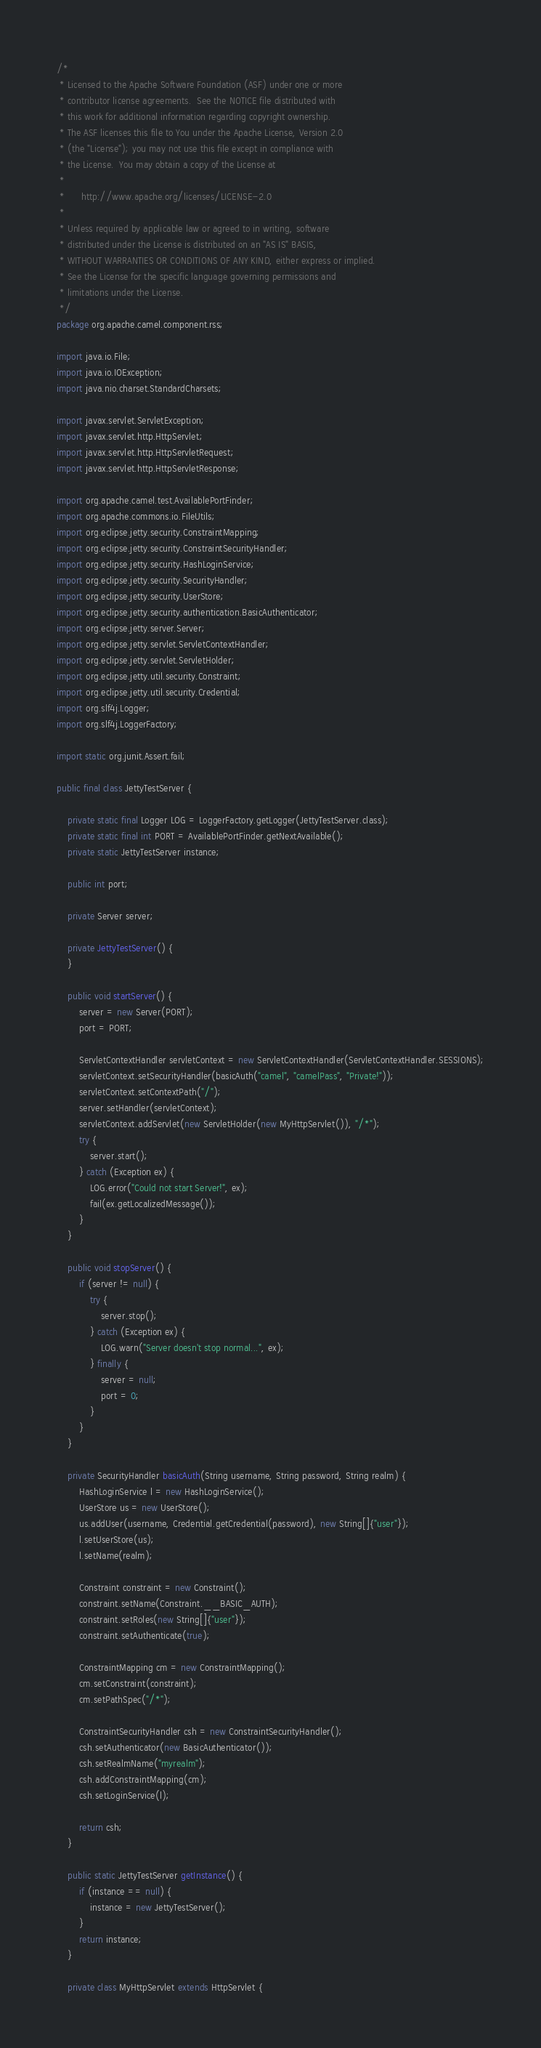<code> <loc_0><loc_0><loc_500><loc_500><_Java_>/*
 * Licensed to the Apache Software Foundation (ASF) under one or more
 * contributor license agreements.  See the NOTICE file distributed with
 * this work for additional information regarding copyright ownership.
 * The ASF licenses this file to You under the Apache License, Version 2.0
 * (the "License"); you may not use this file except in compliance with
 * the License.  You may obtain a copy of the License at
 *
 *      http://www.apache.org/licenses/LICENSE-2.0
 *
 * Unless required by applicable law or agreed to in writing, software
 * distributed under the License is distributed on an "AS IS" BASIS,
 * WITHOUT WARRANTIES OR CONDITIONS OF ANY KIND, either express or implied.
 * See the License for the specific language governing permissions and
 * limitations under the License.
 */
package org.apache.camel.component.rss;

import java.io.File;
import java.io.IOException;
import java.nio.charset.StandardCharsets;

import javax.servlet.ServletException;
import javax.servlet.http.HttpServlet;
import javax.servlet.http.HttpServletRequest;
import javax.servlet.http.HttpServletResponse;

import org.apache.camel.test.AvailablePortFinder;
import org.apache.commons.io.FileUtils;
import org.eclipse.jetty.security.ConstraintMapping;
import org.eclipse.jetty.security.ConstraintSecurityHandler;
import org.eclipse.jetty.security.HashLoginService;
import org.eclipse.jetty.security.SecurityHandler;
import org.eclipse.jetty.security.UserStore;
import org.eclipse.jetty.security.authentication.BasicAuthenticator;
import org.eclipse.jetty.server.Server;
import org.eclipse.jetty.servlet.ServletContextHandler;
import org.eclipse.jetty.servlet.ServletHolder;
import org.eclipse.jetty.util.security.Constraint;
import org.eclipse.jetty.util.security.Credential;
import org.slf4j.Logger;
import org.slf4j.LoggerFactory;

import static org.junit.Assert.fail;

public final class JettyTestServer {

    private static final Logger LOG = LoggerFactory.getLogger(JettyTestServer.class);
    private static final int PORT = AvailablePortFinder.getNextAvailable();
    private static JettyTestServer instance;

    public int port;

    private Server server;

    private JettyTestServer() {
    }

    public void startServer() {
        server = new Server(PORT);
        port = PORT;

        ServletContextHandler servletContext = new ServletContextHandler(ServletContextHandler.SESSIONS);
        servletContext.setSecurityHandler(basicAuth("camel", "camelPass", "Private!"));
        servletContext.setContextPath("/");
        server.setHandler(servletContext);
        servletContext.addServlet(new ServletHolder(new MyHttpServlet()), "/*");
        try {
            server.start();
        } catch (Exception ex) {
            LOG.error("Could not start Server!", ex);
            fail(ex.getLocalizedMessage());
        }
    }

    public void stopServer() {
        if (server != null) {
            try {
                server.stop();
            } catch (Exception ex) {
                LOG.warn("Server doesn't stop normal...", ex);
            } finally {
                server = null;
                port = 0;
            }
        }
    }

    private SecurityHandler basicAuth(String username, String password, String realm) {
        HashLoginService l = new HashLoginService();
        UserStore us = new UserStore();
        us.addUser(username, Credential.getCredential(password), new String[]{"user"});
        l.setUserStore(us);
        l.setName(realm);

        Constraint constraint = new Constraint();
        constraint.setName(Constraint.__BASIC_AUTH);
        constraint.setRoles(new String[]{"user"});
        constraint.setAuthenticate(true);

        ConstraintMapping cm = new ConstraintMapping();
        cm.setConstraint(constraint);
        cm.setPathSpec("/*");

        ConstraintSecurityHandler csh = new ConstraintSecurityHandler();
        csh.setAuthenticator(new BasicAuthenticator());
        csh.setRealmName("myrealm");
        csh.addConstraintMapping(cm);
        csh.setLoginService(l);

        return csh;
    }

    public static JettyTestServer getInstance() {
        if (instance == null) {
            instance = new JettyTestServer();
        }
        return instance;
    }

    private class MyHttpServlet extends HttpServlet {
</code> 